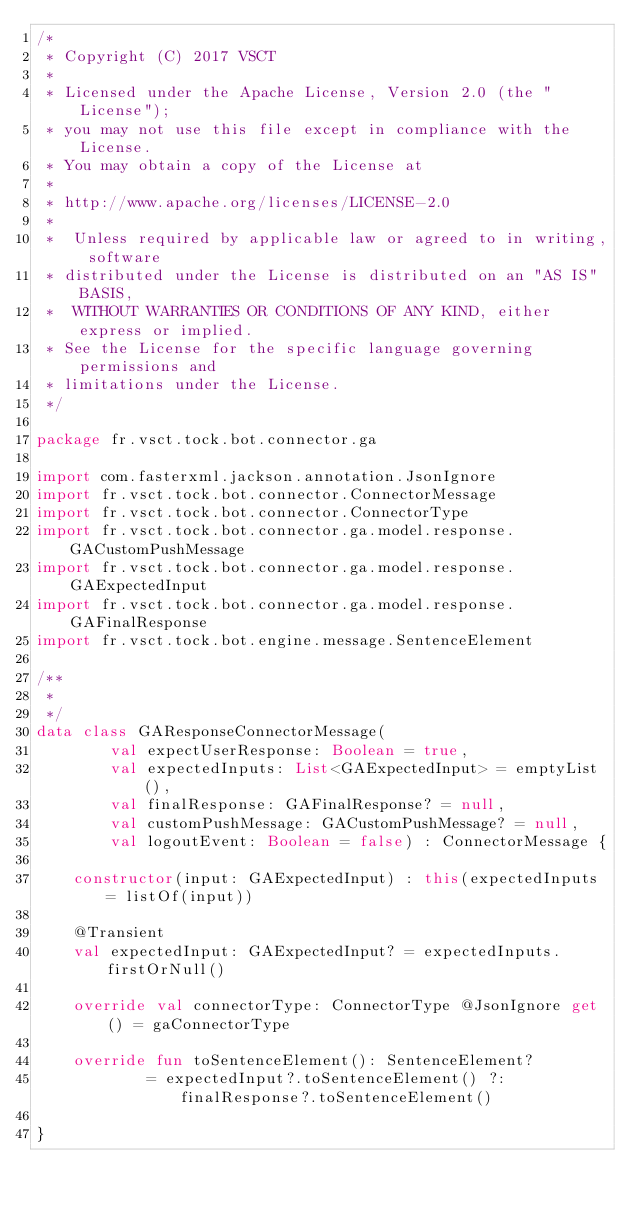<code> <loc_0><loc_0><loc_500><loc_500><_Kotlin_>/*
 * Copyright (C) 2017 VSCT
 *
 * Licensed under the Apache License, Version 2.0 (the "License");
 * you may not use this file except in compliance with the License.
 * You may obtain a copy of the License at
 *
 * http://www.apache.org/licenses/LICENSE-2.0
 *
 *  Unless required by applicable law or agreed to in writing, software
 * distributed under the License is distributed on an "AS IS" BASIS,
 *  WITHOUT WARRANTIES OR CONDITIONS OF ANY KIND, either express or implied.
 * See the License for the specific language governing permissions and
 * limitations under the License.
 */

package fr.vsct.tock.bot.connector.ga

import com.fasterxml.jackson.annotation.JsonIgnore
import fr.vsct.tock.bot.connector.ConnectorMessage
import fr.vsct.tock.bot.connector.ConnectorType
import fr.vsct.tock.bot.connector.ga.model.response.GACustomPushMessage
import fr.vsct.tock.bot.connector.ga.model.response.GAExpectedInput
import fr.vsct.tock.bot.connector.ga.model.response.GAFinalResponse
import fr.vsct.tock.bot.engine.message.SentenceElement

/**
 *
 */
data class GAResponseConnectorMessage(
        val expectUserResponse: Boolean = true,
        val expectedInputs: List<GAExpectedInput> = emptyList(),
        val finalResponse: GAFinalResponse? = null,
        val customPushMessage: GACustomPushMessage? = null,
        val logoutEvent: Boolean = false) : ConnectorMessage {

    constructor(input: GAExpectedInput) : this(expectedInputs = listOf(input))

    @Transient
    val expectedInput: GAExpectedInput? = expectedInputs.firstOrNull()

    override val connectorType: ConnectorType @JsonIgnore get() = gaConnectorType

    override fun toSentenceElement(): SentenceElement?
            = expectedInput?.toSentenceElement() ?: finalResponse?.toSentenceElement()

}</code> 